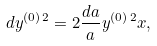<formula> <loc_0><loc_0><loc_500><loc_500>d y ^ { ( 0 ) { \, } 2 } = 2 \frac { d a } { a } y ^ { ( 0 ) { \, } 2 } x ,</formula> 